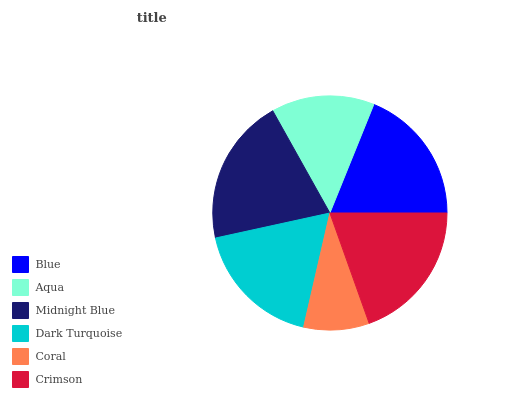Is Coral the minimum?
Answer yes or no. Yes. Is Midnight Blue the maximum?
Answer yes or no. Yes. Is Aqua the minimum?
Answer yes or no. No. Is Aqua the maximum?
Answer yes or no. No. Is Blue greater than Aqua?
Answer yes or no. Yes. Is Aqua less than Blue?
Answer yes or no. Yes. Is Aqua greater than Blue?
Answer yes or no. No. Is Blue less than Aqua?
Answer yes or no. No. Is Blue the high median?
Answer yes or no. Yes. Is Dark Turquoise the low median?
Answer yes or no. Yes. Is Crimson the high median?
Answer yes or no. No. Is Blue the low median?
Answer yes or no. No. 